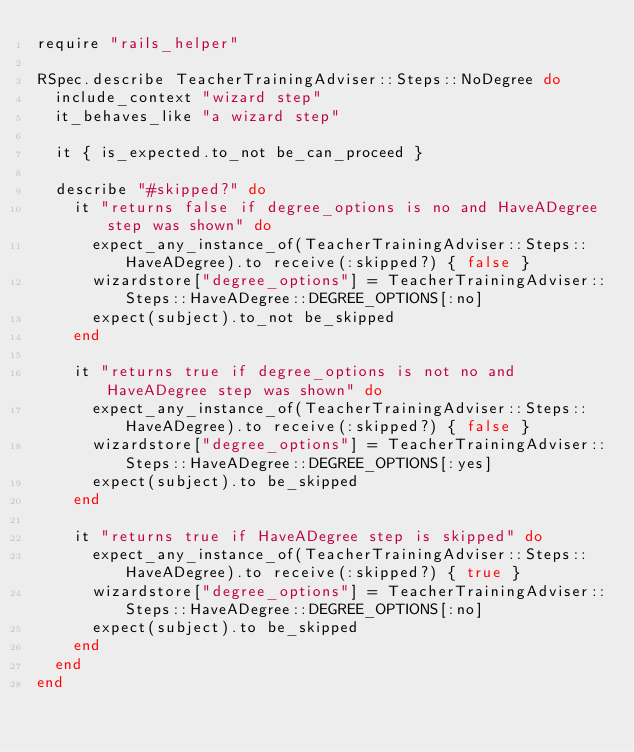Convert code to text. <code><loc_0><loc_0><loc_500><loc_500><_Ruby_>require "rails_helper"

RSpec.describe TeacherTrainingAdviser::Steps::NoDegree do
  include_context "wizard step"
  it_behaves_like "a wizard step"

  it { is_expected.to_not be_can_proceed }

  describe "#skipped?" do
    it "returns false if degree_options is no and HaveADegree step was shown" do
      expect_any_instance_of(TeacherTrainingAdviser::Steps::HaveADegree).to receive(:skipped?) { false }
      wizardstore["degree_options"] = TeacherTrainingAdviser::Steps::HaveADegree::DEGREE_OPTIONS[:no]
      expect(subject).to_not be_skipped
    end

    it "returns true if degree_options is not no and HaveADegree step was shown" do
      expect_any_instance_of(TeacherTrainingAdviser::Steps::HaveADegree).to receive(:skipped?) { false }
      wizardstore["degree_options"] = TeacherTrainingAdviser::Steps::HaveADegree::DEGREE_OPTIONS[:yes]
      expect(subject).to be_skipped
    end

    it "returns true if HaveADegree step is skipped" do
      expect_any_instance_of(TeacherTrainingAdviser::Steps::HaveADegree).to receive(:skipped?) { true }
      wizardstore["degree_options"] = TeacherTrainingAdviser::Steps::HaveADegree::DEGREE_OPTIONS[:no]
      expect(subject).to be_skipped
    end
  end
end
</code> 